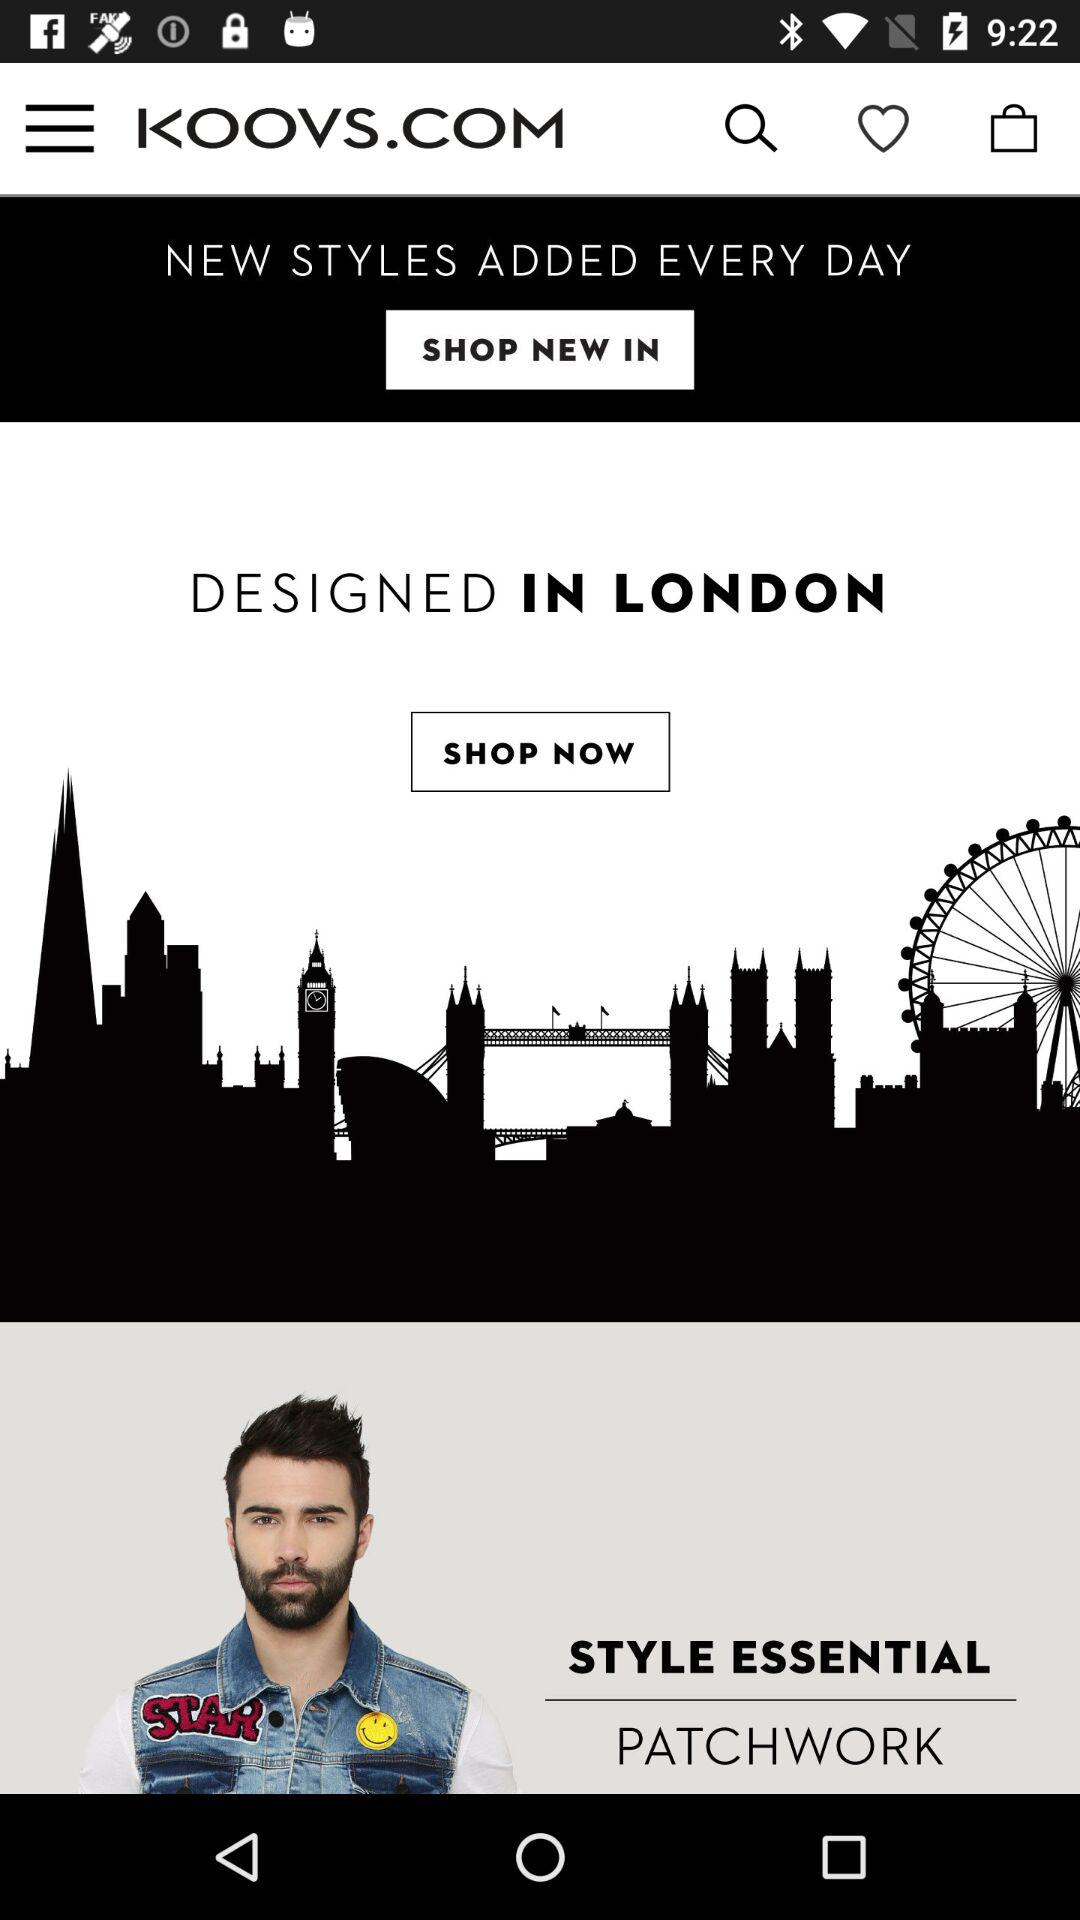What is the app name?
Answer the question using a single word or phrase. The app name is "KOOVS.COM" 